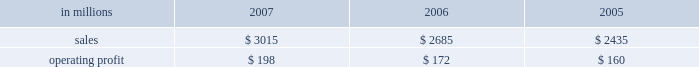Asian industrial packaging net sales for 2007 were $ 265 million compared with $ 180 million in 2006 .
In 2005 , net sales were $ 105 million sub- sequent to international paper 2019s acquisition of a majority interest in this business in august 2005 .
Operating profits totaled $ 6 million in 2007 and $ 3 million in 2006 , compared with a loss of $ 4 million in consumer packaging demand and pricing for consumer packaging prod- ucts correlate closely with consumer spending and general economic activity .
In addition to prices and volumes , major factors affecting the profitability of consumer packaging are raw material and energy costs , freight costs , manufacturing efficiency and product mix .
Consumer packaging net sales increased 12% ( 12 % ) compared with 2006 and 24% ( 24 % ) compared with 2005 .
Operating profits rose 15% ( 15 % ) from 2006 and 24% ( 24 % ) from 2005 levels .
Benefits from improved average sales price realizations ( $ 52 million ) , higher sales volumes for u.s .
And european coated paperboard ( $ 9 million ) , favorable mill operations ( $ 14 million ) and contributions from international paper & sun cartonboard co. , ltd .
Acquired in 2006 ( $ 16 million ) , were partially offset by higher raw material and energy costs ( $ 53 million ) , an unfavorable mix of products sold ( $ 4 million ) , increased freight costs ( $ 5 million ) and other costs ( $ 3 million ) .
Consumer packaging in millions 2007 2006 2005 .
North american consumer packaging net sales were $ 2.4 billion in both 2007 and 2006 com- pared with $ 2.2 billion in 2005 .
Operating earnings of $ 143 million in 2007 improved from $ 129 million in 2006 and $ 121 million in 2005 .
Coated paperboard sales volumes increased in 2007 compared with 2006 , particularly for folding carton board , reflecting improved demand .
Average sales price realizations substantially improved in 2007 for both folding carton board and cup stock .
The impact of the higher sales prices combined with improved manufacturing performance at our mills more than offset the negative effects of higher wood and energy costs .
Foodservice sales volumes were slightly higher in 2007 than in 2006 .
Average sales prices were also higher reflecting the realization of price increases implemented to recover raw material cost increases .
In addition , a more favorable mix of hot cups and food containers led to higher average margins .
Raw material costs for bleached board and polystyrene were higher than in 2006 , but these increases were partially offset by improved manufacturing costs reflecting increased productivity and reduced waste .
Shorewood sales volumes in 2007 declined from 2006 levels due to weak demand in the home enter- tainment , tobacco and display markets , although demand was stronger in the consumer products segment .
Sales margins declined from 2006 reflect- ing a less favorable mix of products sold .
Raw material costs were higher for bleached board , but this impact was more than offset by improved manufacturing operations and lower operating costs .
Charges to restructure operations also impacted 2007 results .
Entering 2008 , coated paperboard sales volumes are expected to be about even with the fourth quarter of 2007 , while average sales price realizations are expected to slightly improve .
Earnings should bene- fit from fewer planned mill maintenance outages compared with the 2007 fourth quarter .
However , costs for wood , polyethylene and energy are expected to be higher .
Foodservice results are expected to benefit from increased sales volumes and higher sales price realizations .
Shorewood sales volumes for the first quarter 2008 are expected to seasonally decline , but this negative impact should be partially offset by benefits from cost improve- ments associated with prior-year restructuring actions .
European consumer packaging net sales in 2007 were $ 280 million compared with $ 230 million in 2006 and $ 190 million in 2005 .
Sales volumes in 2007 were higher than in 2006 reflecting stronger market demand and improved productivity at our kwidzyn mill .
Average sales price realizations also improved in 2007 .
Operating earnings in 2007 of $ 37 million declined from $ 41 million in 2006 and $ 39 million in 2005 .
The additional contribution from higher net sales was more than offset by higher input costs for wood , energy and freight .
Entering 2008 , sales volumes and prices are expected to be comparable to the fourth quarter .
Machine performance and sales mix are expected to improve ; however , wood costs are expected to be higher , especially in russia due to strong demand ahead of tariff increases , and energy costs are anticipated to be seasonally higher. .
What percentage of consumer packaging sales cam from european consumer packaging net sales in 2006? 
Computations: (230 / 2685)
Answer: 0.08566. Asian industrial packaging net sales for 2007 were $ 265 million compared with $ 180 million in 2006 .
In 2005 , net sales were $ 105 million sub- sequent to international paper 2019s acquisition of a majority interest in this business in august 2005 .
Operating profits totaled $ 6 million in 2007 and $ 3 million in 2006 , compared with a loss of $ 4 million in consumer packaging demand and pricing for consumer packaging prod- ucts correlate closely with consumer spending and general economic activity .
In addition to prices and volumes , major factors affecting the profitability of consumer packaging are raw material and energy costs , freight costs , manufacturing efficiency and product mix .
Consumer packaging net sales increased 12% ( 12 % ) compared with 2006 and 24% ( 24 % ) compared with 2005 .
Operating profits rose 15% ( 15 % ) from 2006 and 24% ( 24 % ) from 2005 levels .
Benefits from improved average sales price realizations ( $ 52 million ) , higher sales volumes for u.s .
And european coated paperboard ( $ 9 million ) , favorable mill operations ( $ 14 million ) and contributions from international paper & sun cartonboard co. , ltd .
Acquired in 2006 ( $ 16 million ) , were partially offset by higher raw material and energy costs ( $ 53 million ) , an unfavorable mix of products sold ( $ 4 million ) , increased freight costs ( $ 5 million ) and other costs ( $ 3 million ) .
Consumer packaging in millions 2007 2006 2005 .
North american consumer packaging net sales were $ 2.4 billion in both 2007 and 2006 com- pared with $ 2.2 billion in 2005 .
Operating earnings of $ 143 million in 2007 improved from $ 129 million in 2006 and $ 121 million in 2005 .
Coated paperboard sales volumes increased in 2007 compared with 2006 , particularly for folding carton board , reflecting improved demand .
Average sales price realizations substantially improved in 2007 for both folding carton board and cup stock .
The impact of the higher sales prices combined with improved manufacturing performance at our mills more than offset the negative effects of higher wood and energy costs .
Foodservice sales volumes were slightly higher in 2007 than in 2006 .
Average sales prices were also higher reflecting the realization of price increases implemented to recover raw material cost increases .
In addition , a more favorable mix of hot cups and food containers led to higher average margins .
Raw material costs for bleached board and polystyrene were higher than in 2006 , but these increases were partially offset by improved manufacturing costs reflecting increased productivity and reduced waste .
Shorewood sales volumes in 2007 declined from 2006 levels due to weak demand in the home enter- tainment , tobacco and display markets , although demand was stronger in the consumer products segment .
Sales margins declined from 2006 reflect- ing a less favorable mix of products sold .
Raw material costs were higher for bleached board , but this impact was more than offset by improved manufacturing operations and lower operating costs .
Charges to restructure operations also impacted 2007 results .
Entering 2008 , coated paperboard sales volumes are expected to be about even with the fourth quarter of 2007 , while average sales price realizations are expected to slightly improve .
Earnings should bene- fit from fewer planned mill maintenance outages compared with the 2007 fourth quarter .
However , costs for wood , polyethylene and energy are expected to be higher .
Foodservice results are expected to benefit from increased sales volumes and higher sales price realizations .
Shorewood sales volumes for the first quarter 2008 are expected to seasonally decline , but this negative impact should be partially offset by benefits from cost improve- ments associated with prior-year restructuring actions .
European consumer packaging net sales in 2007 were $ 280 million compared with $ 230 million in 2006 and $ 190 million in 2005 .
Sales volumes in 2007 were higher than in 2006 reflecting stronger market demand and improved productivity at our kwidzyn mill .
Average sales price realizations also improved in 2007 .
Operating earnings in 2007 of $ 37 million declined from $ 41 million in 2006 and $ 39 million in 2005 .
The additional contribution from higher net sales was more than offset by higher input costs for wood , energy and freight .
Entering 2008 , sales volumes and prices are expected to be comparable to the fourth quarter .
Machine performance and sales mix are expected to improve ; however , wood costs are expected to be higher , especially in russia due to strong demand ahead of tariff increases , and energy costs are anticipated to be seasonally higher. .
What was the consumer packaging profit margin in 2006? 
Computations: (172 / 2685)
Answer: 0.06406. 